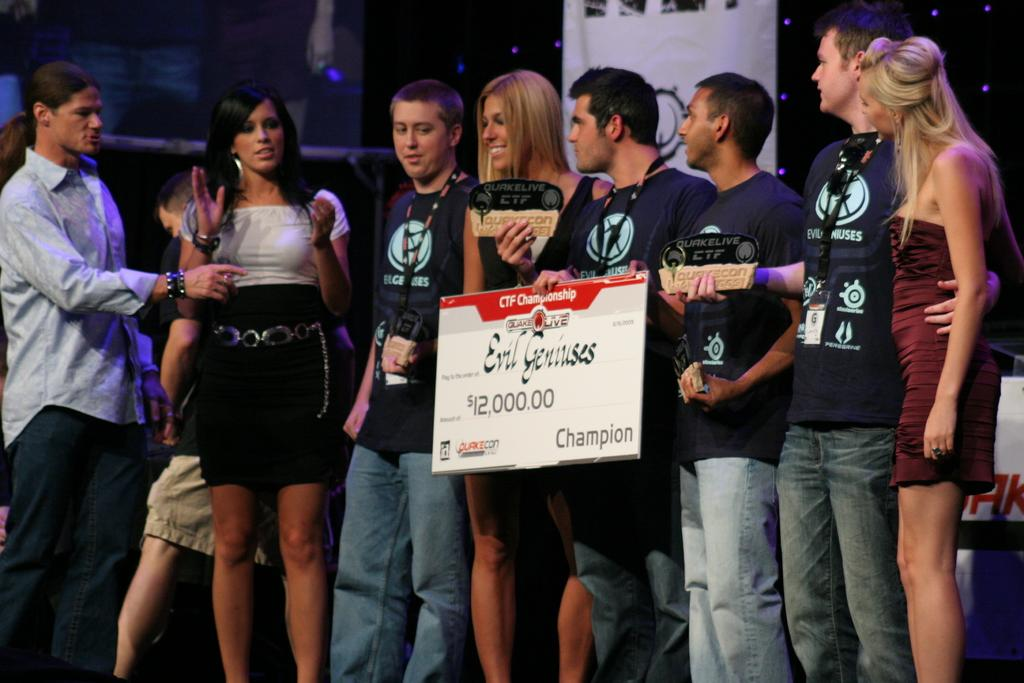What is happening in the image involving the group of people? There is a group of people standing on a stage. What object is being held by one of the people? A person is holding a chessboard. What might be a reason for the people to be holding awards? Some people are holding awards, which suggests they may have won or been recognized for something. What type of popcorn is being served on the sidewalk in the image? There is no popcorn or sidewalk present in the image. 